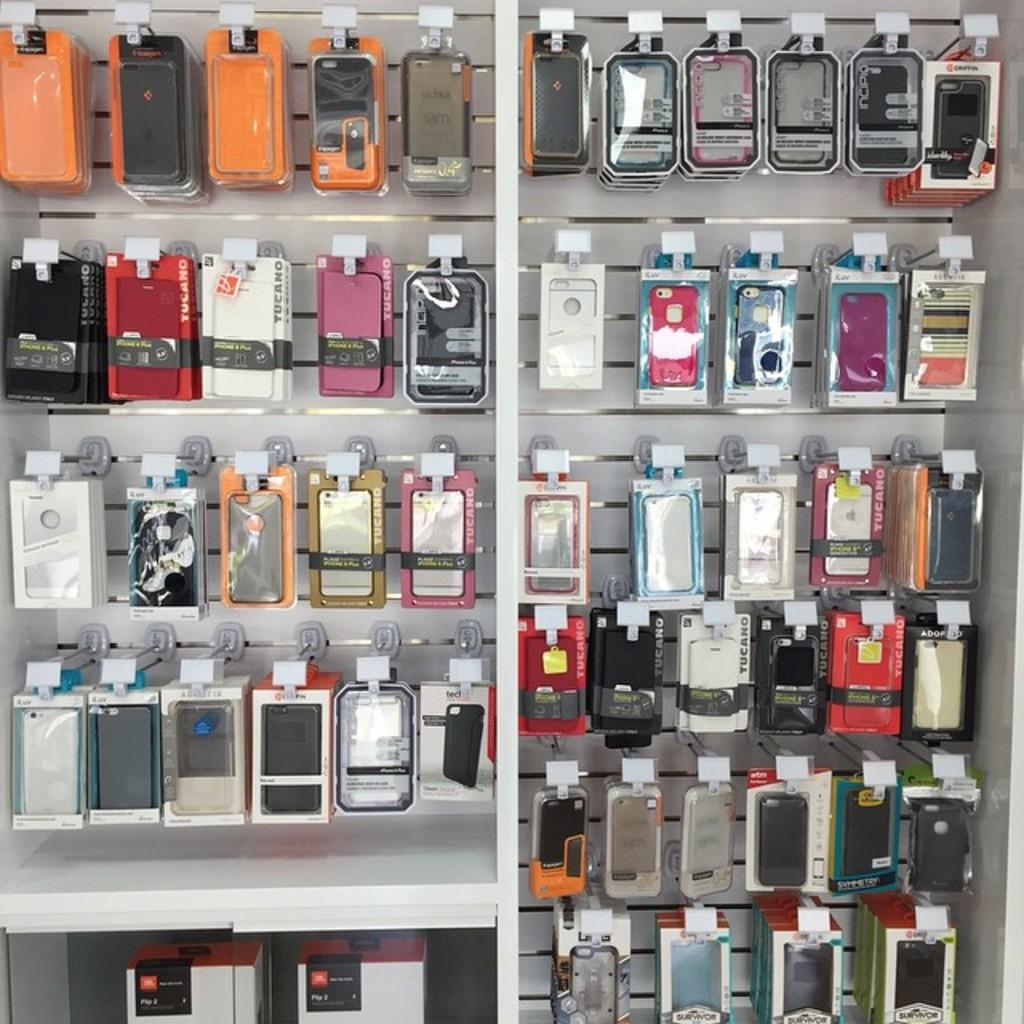What type of containers are visible in the image? There are plastic boxes in the image. What items can be found inside the plastic boxes? Phone cases are inside the plastic boxes. Where is the mother wearing a vest in the image? There is no mother or vest present in the image; it only features plastic boxes with phone cases inside. 